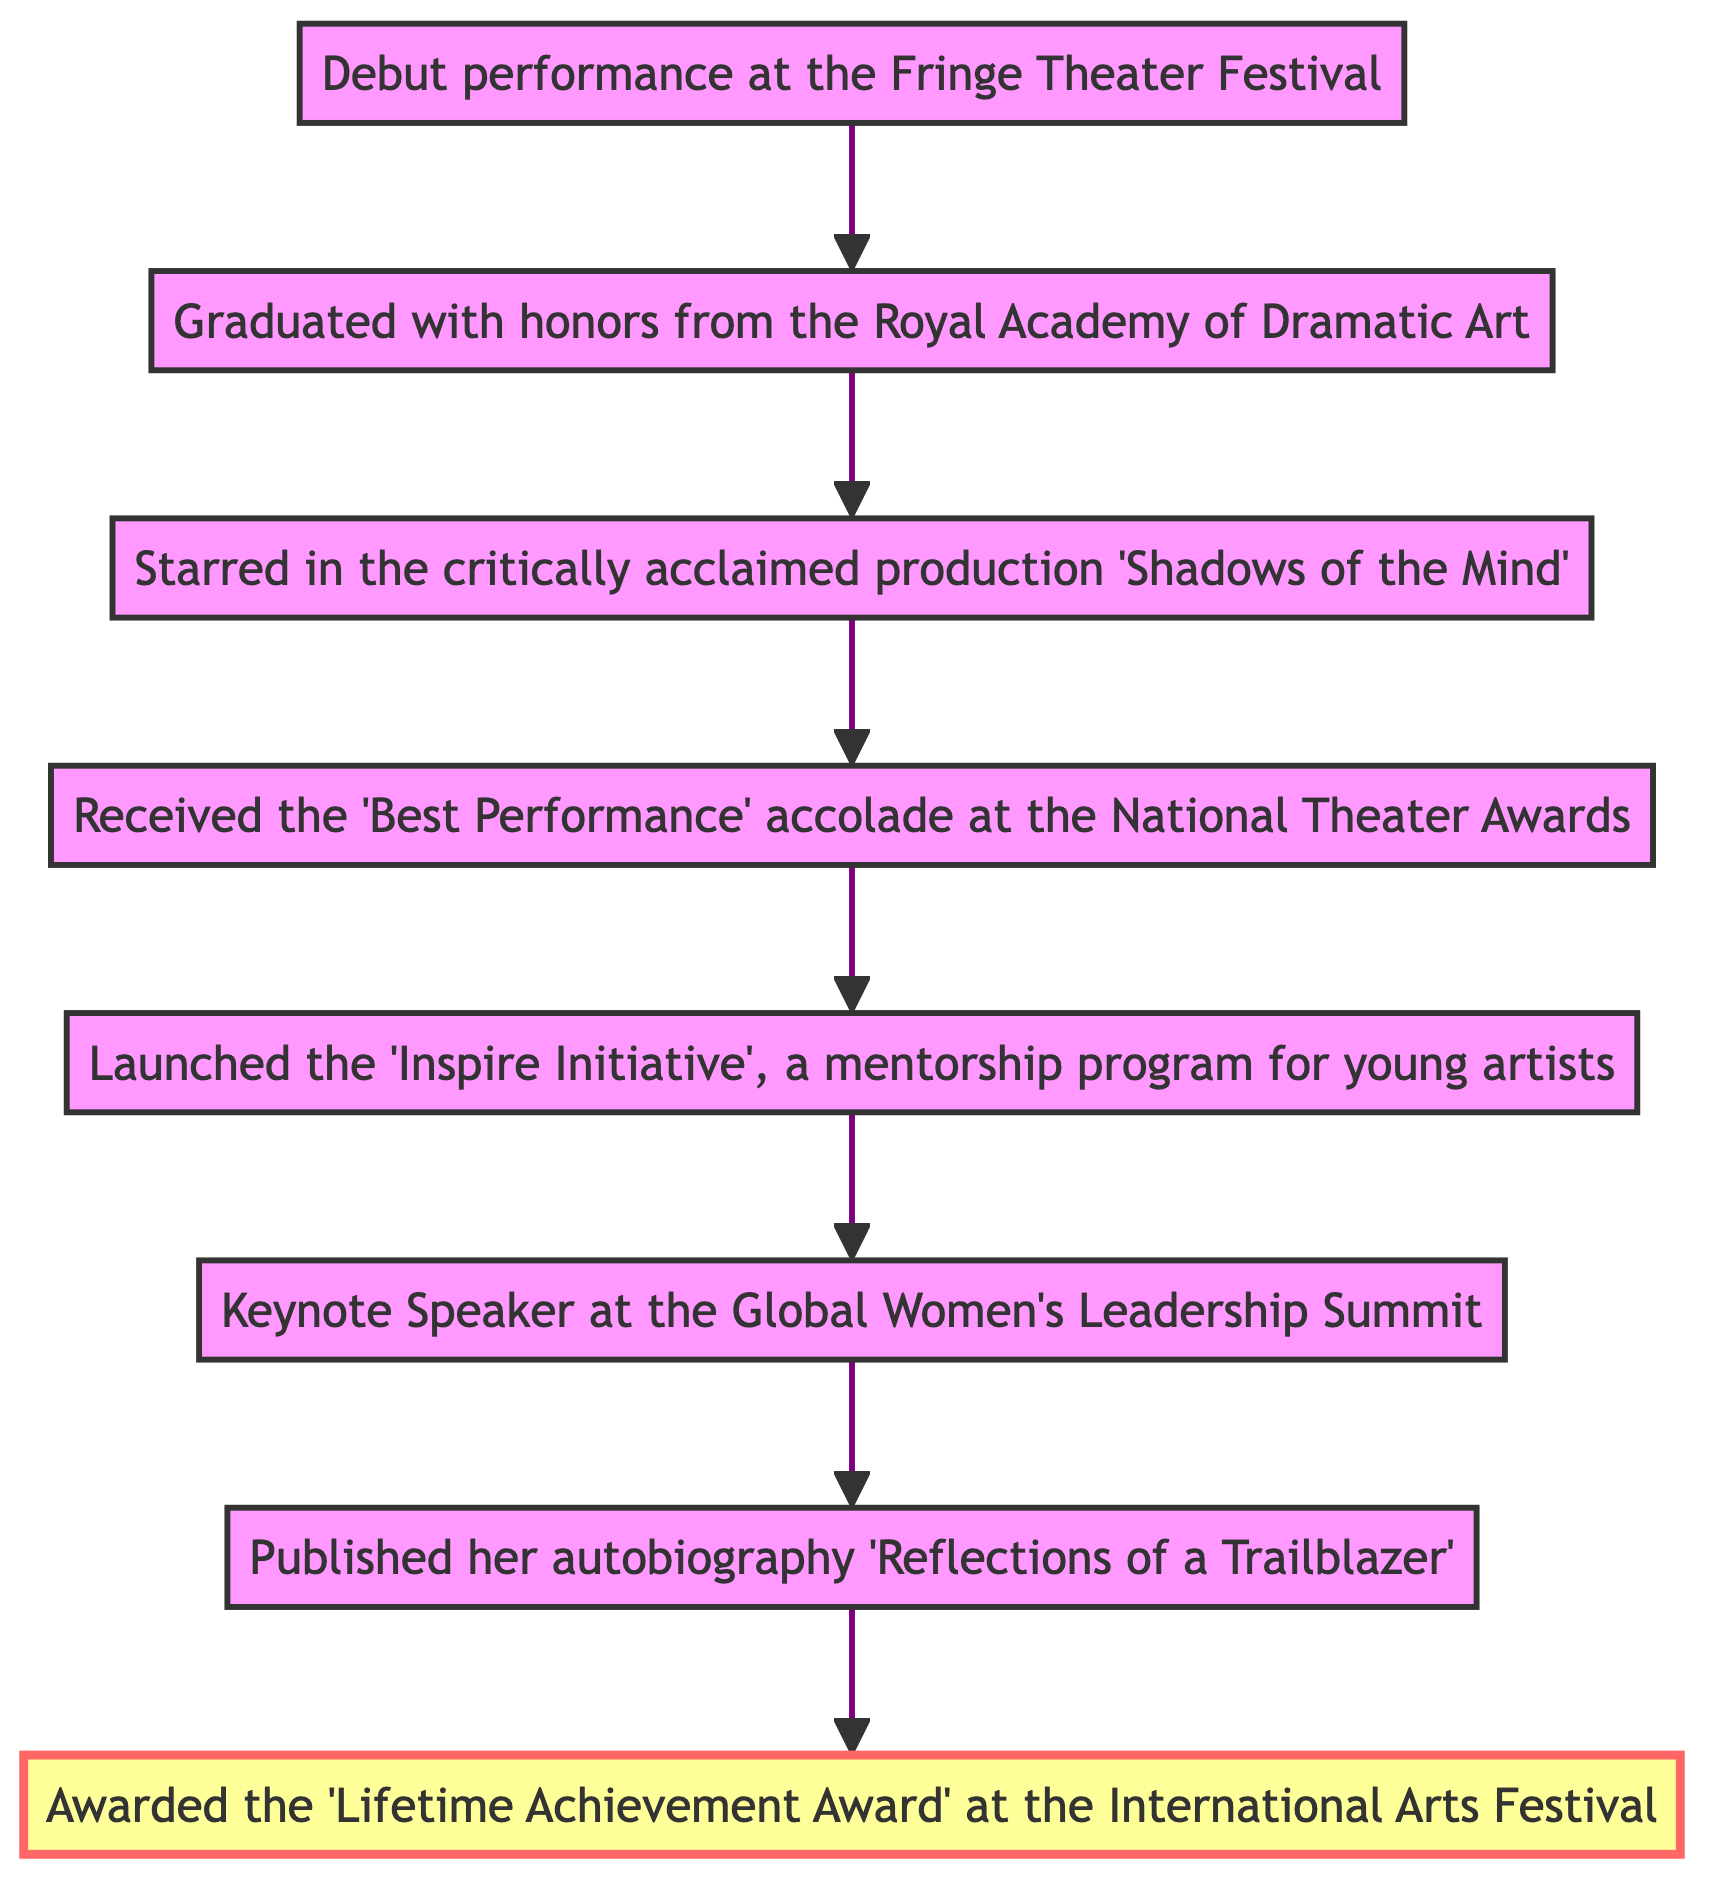What is the last highlighted node in the diagram? The last node in the diagram is labeled "Awarded the 'Lifetime Achievement Award' at the International Arts Festival," and it is highlighted.
Answer: Awarded the 'Lifetime Achievement Award' at the International Arts Festival How many nodes are represented in the flowchart? The flowchart consists of 8 nodes, starting from the initial step to the recent highlight.
Answer: 8 What achievement comes directly after the 'Inspire Initiative'? The 'Inspire Initiative' node is followed by the node indicating her role as a keynote speaker at the summit.
Answer: Keynote Speaker at the Global Women's Leadership Summit Which node corresponds to Melanie Walker's earliest career activity? The initial step at the bottom of the diagram indicates her debut performance, making it the earliest career activity.
Answer: Debut performance at the Fringe Theater Festival What progression of events leads to the publication of her autobiography? The flow from the 'Inspire Initiative' to the keynote speaking event, before culminating in the publication of her autobiography.
Answer: Launched the 'Inspire Initiative' → Keynote Speaker → Published her autobiography 'Reflections of a Trailblazer' What is the second node from the bottom? The second node from the bottom after the initial step is where she graduated with honors from the Royal Academy of Dramatic Art.
Answer: Graduated with honors from the Royal Academy of Dramatic Art Identify the connection between 'Shadows of the Mind' and 'Best Performance' accolade. 'Shadows of the Mind' is a breakthrough role that connects to the achievement where she received the 'Best Performance' accolade, showing a progression of success.
Answer: Starred in the critically acclaimed production 'Shadows of the Mind' → Received the 'Best Performance' accolade at the National Theater Awards What milestone occurs immediately before the publication of her autobiography? The publication of her autobiography follows her recognition as a keynote speaker, which is the direct precursor.
Answer: Keynote Speaker at the Global Women's Leadership Summit 